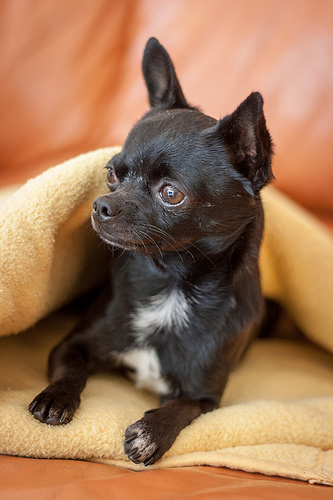<image>
Is the dog on the floor? No. The dog is not positioned on the floor. They may be near each other, but the dog is not supported by or resting on top of the floor. Is there a dog under the blanket? Yes. The dog is positioned underneath the blanket, with the blanket above it in the vertical space. 